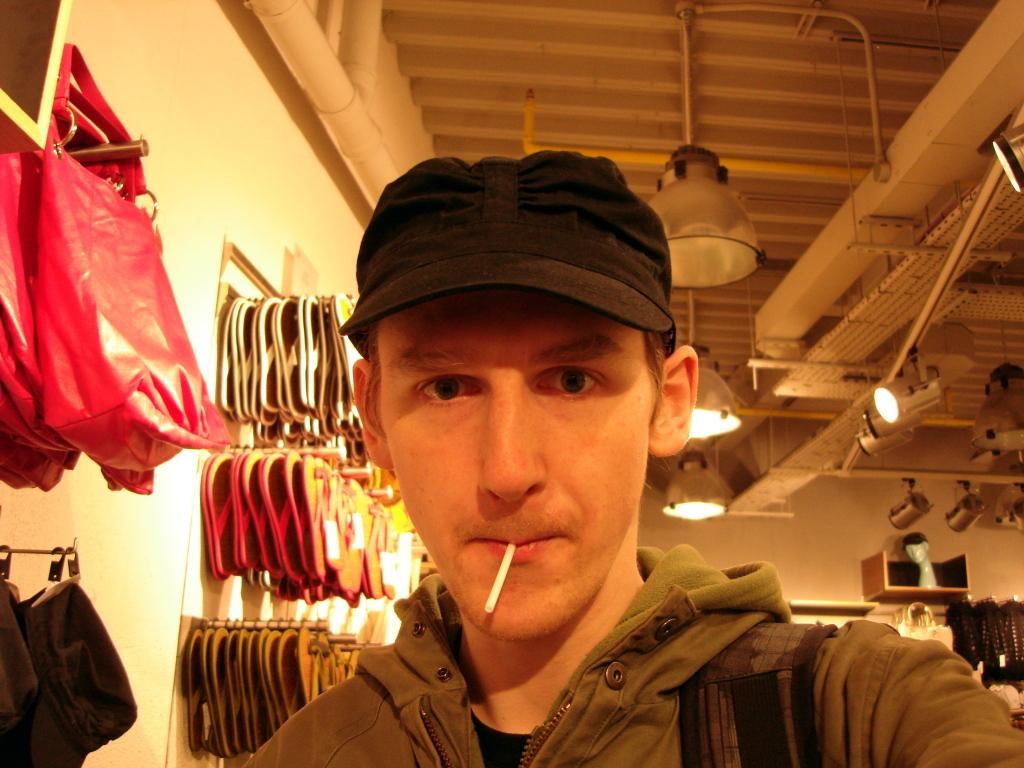Who is the main subject in the image? There is a boy in the center of the image. What can be seen on the roof in the image? There are lamps on the roof. What items are present in the image besides the boy? There are bags and slippers in the image. Where are the bags and slippers located in the image? The bags and slippers are hanged behind the boy. What type of animal is sitting next to the boy in the image? There is no animal present in the image; the boy is alone in the center. 